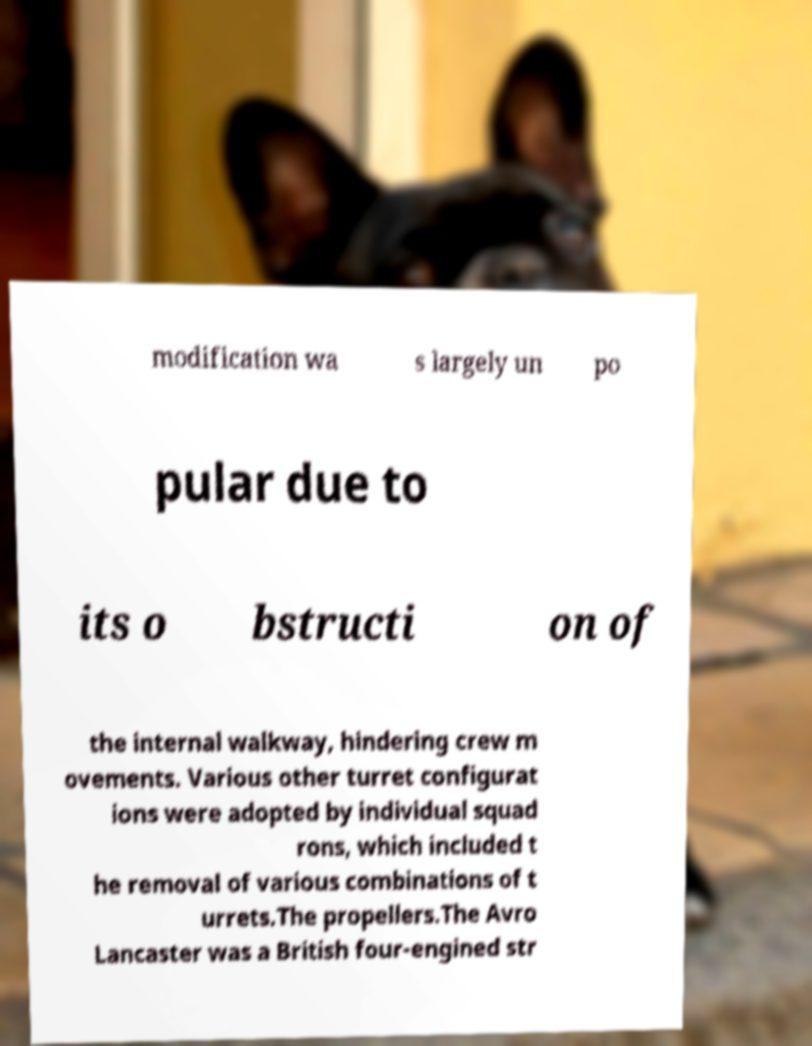For documentation purposes, I need the text within this image transcribed. Could you provide that? modification wa s largely un po pular due to its o bstructi on of the internal walkway, hindering crew m ovements. Various other turret configurat ions were adopted by individual squad rons, which included t he removal of various combinations of t urrets.The propellers.The Avro Lancaster was a British four-engined str 